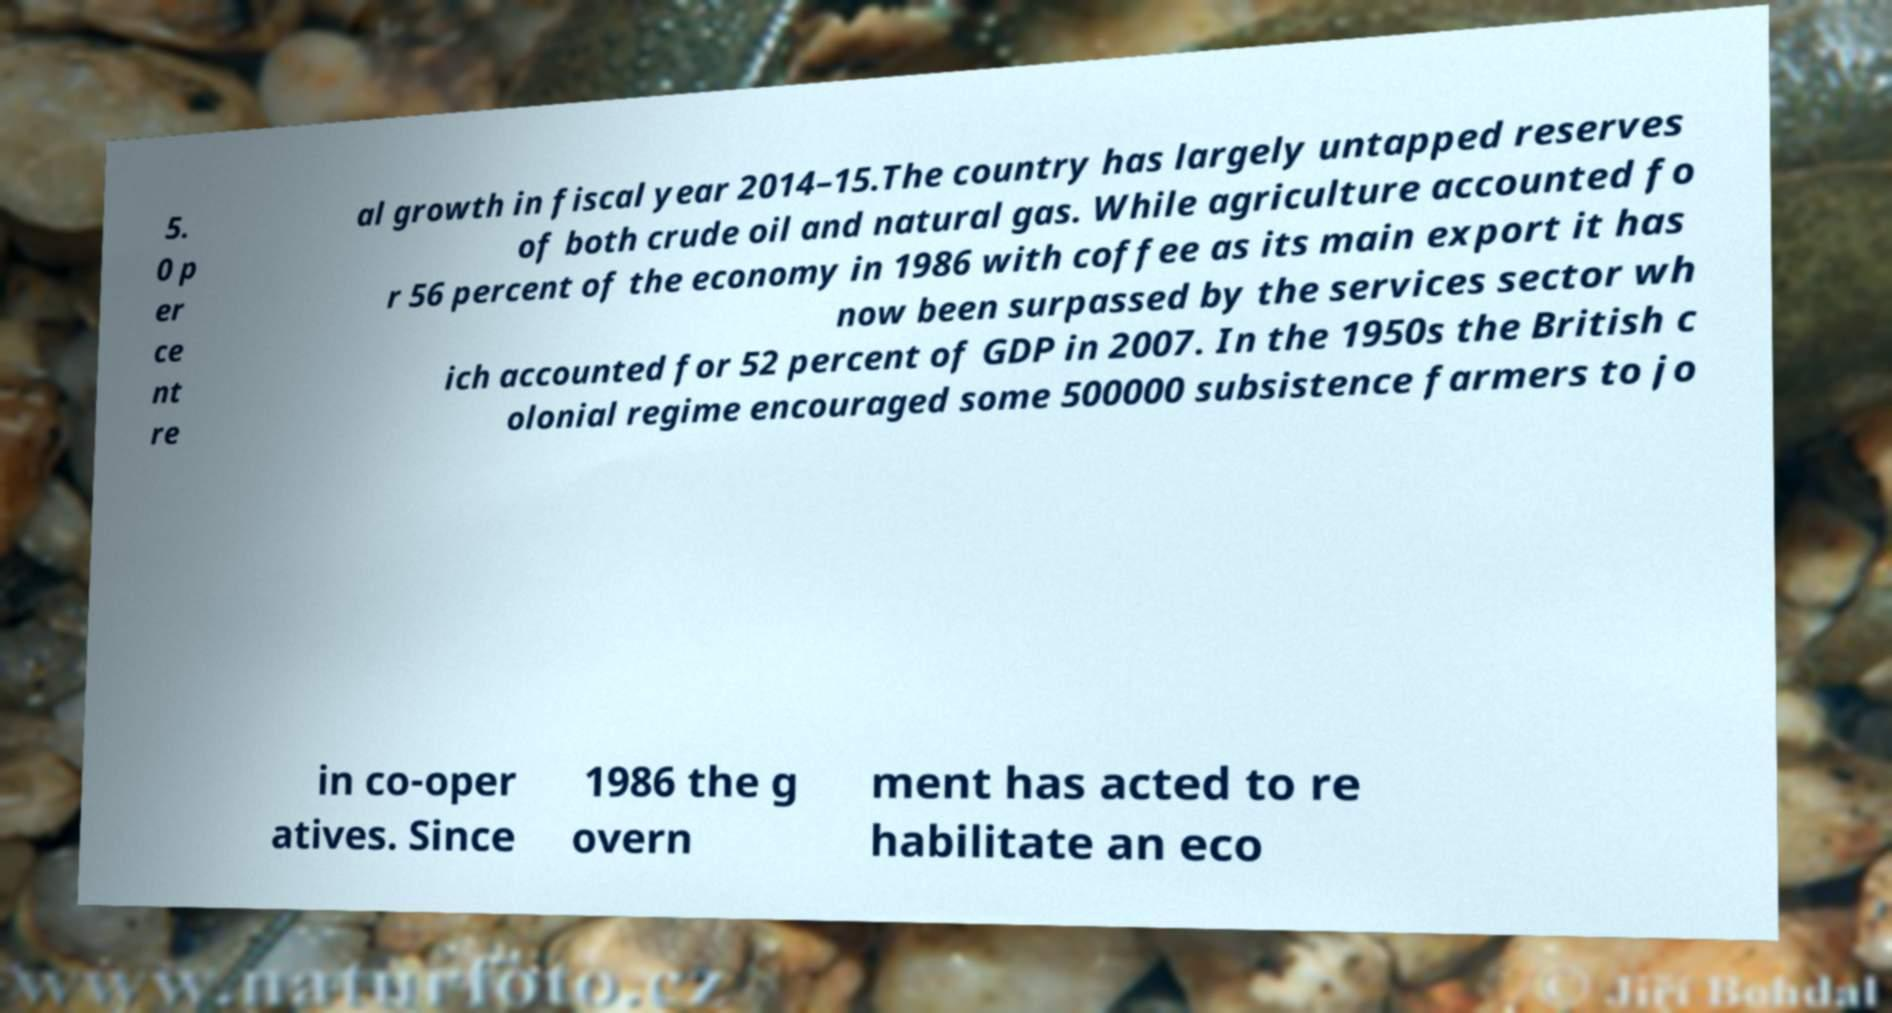Could you assist in decoding the text presented in this image and type it out clearly? 5. 0 p er ce nt re al growth in fiscal year 2014–15.The country has largely untapped reserves of both crude oil and natural gas. While agriculture accounted fo r 56 percent of the economy in 1986 with coffee as its main export it has now been surpassed by the services sector wh ich accounted for 52 percent of GDP in 2007. In the 1950s the British c olonial regime encouraged some 500000 subsistence farmers to jo in co-oper atives. Since 1986 the g overn ment has acted to re habilitate an eco 